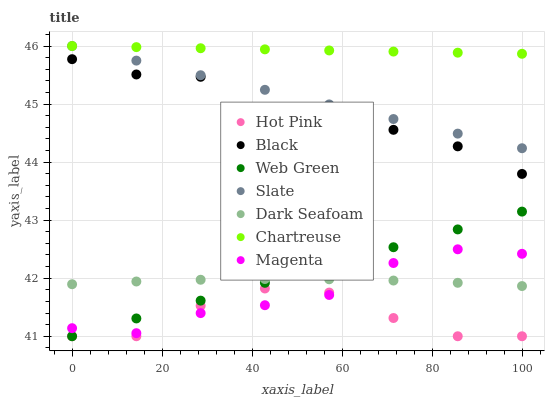Does Hot Pink have the minimum area under the curve?
Answer yes or no. Yes. Does Chartreuse have the maximum area under the curve?
Answer yes or no. Yes. Does Dark Seafoam have the minimum area under the curve?
Answer yes or no. No. Does Dark Seafoam have the maximum area under the curve?
Answer yes or no. No. Is Web Green the smoothest?
Answer yes or no. Yes. Is Hot Pink the roughest?
Answer yes or no. Yes. Is Dark Seafoam the smoothest?
Answer yes or no. No. Is Dark Seafoam the roughest?
Answer yes or no. No. Does Hot Pink have the lowest value?
Answer yes or no. Yes. Does Dark Seafoam have the lowest value?
Answer yes or no. No. Does Chartreuse have the highest value?
Answer yes or no. Yes. Does Dark Seafoam have the highest value?
Answer yes or no. No. Is Dark Seafoam less than Slate?
Answer yes or no. Yes. Is Dark Seafoam greater than Hot Pink?
Answer yes or no. Yes. Does Hot Pink intersect Magenta?
Answer yes or no. Yes. Is Hot Pink less than Magenta?
Answer yes or no. No. Is Hot Pink greater than Magenta?
Answer yes or no. No. Does Dark Seafoam intersect Slate?
Answer yes or no. No. 